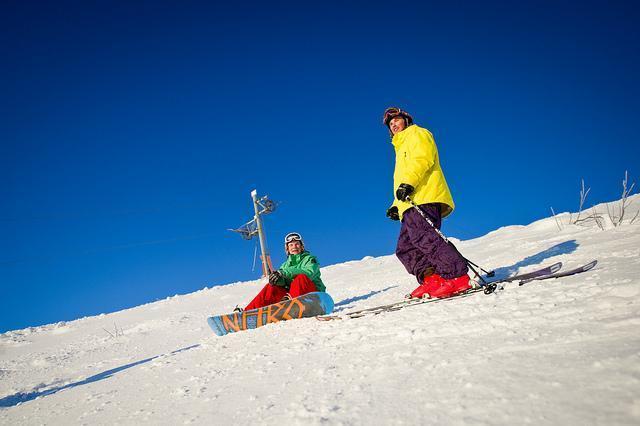How many people can be seen?
Give a very brief answer. 2. 